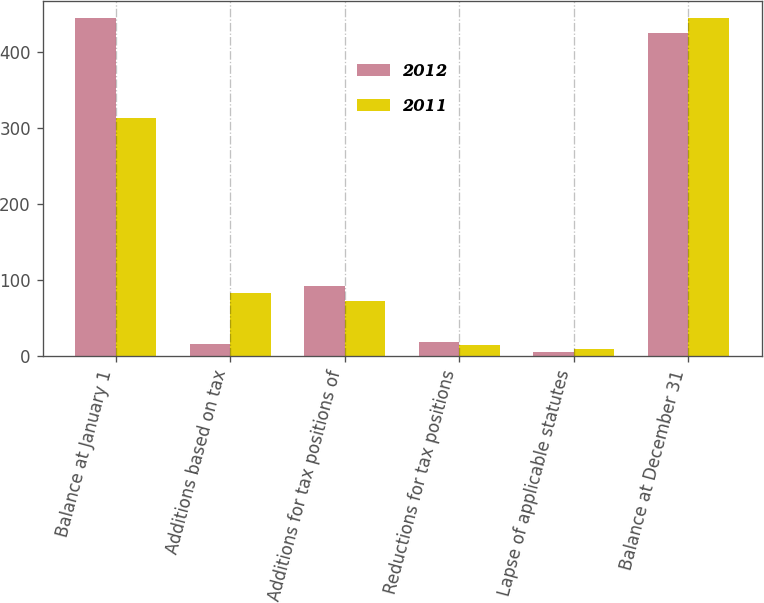Convert chart to OTSL. <chart><loc_0><loc_0><loc_500><loc_500><stacked_bar_chart><ecel><fcel>Balance at January 1<fcel>Additions based on tax<fcel>Additions for tax positions of<fcel>Reductions for tax positions<fcel>Lapse of applicable statutes<fcel>Balance at December 31<nl><fcel>2012<fcel>445<fcel>16<fcel>92<fcel>19<fcel>6<fcel>425<nl><fcel>2011<fcel>313<fcel>83<fcel>73<fcel>15<fcel>9<fcel>445<nl></chart> 